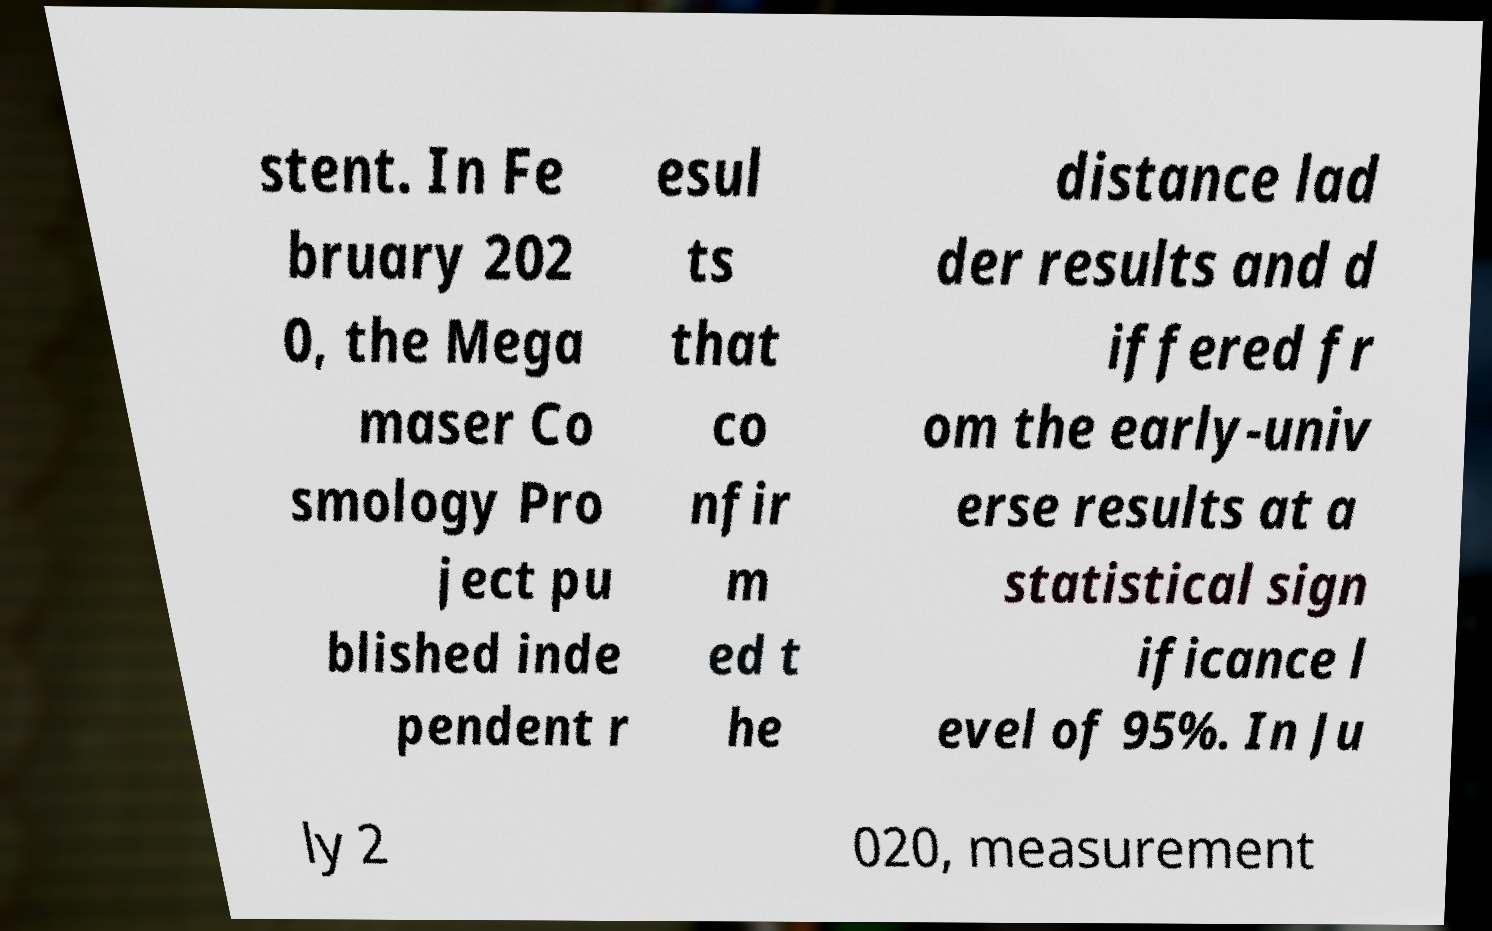Can you read and provide the text displayed in the image?This photo seems to have some interesting text. Can you extract and type it out for me? stent. In Fe bruary 202 0, the Mega maser Co smology Pro ject pu blished inde pendent r esul ts that co nfir m ed t he distance lad der results and d iffered fr om the early-univ erse results at a statistical sign ificance l evel of 95%. In Ju ly 2 020, measurement 